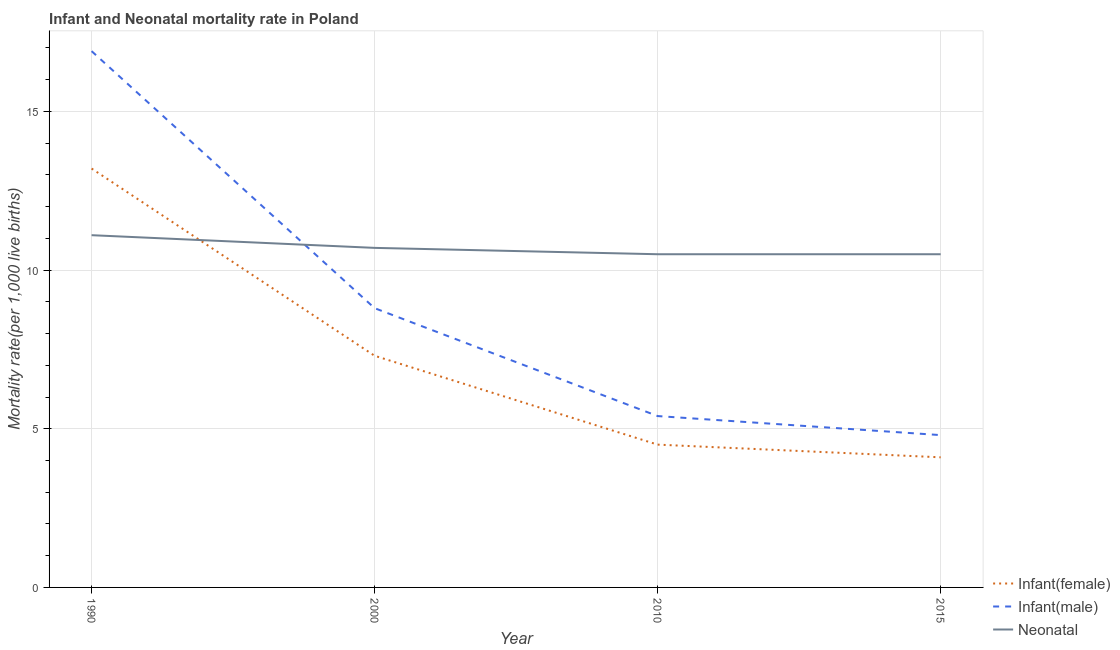Across all years, what is the maximum infant mortality rate(male)?
Provide a succinct answer. 16.9. In which year was the infant mortality rate(female) minimum?
Ensure brevity in your answer.  2015. What is the total infant mortality rate(female) in the graph?
Your answer should be very brief. 29.1. What is the difference between the neonatal mortality rate in 2000 and that in 2010?
Your answer should be very brief. 0.2. What is the difference between the neonatal mortality rate in 2015 and the infant mortality rate(male) in 1990?
Offer a terse response. -6.4. What is the average infant mortality rate(male) per year?
Offer a terse response. 8.97. In the year 2015, what is the difference between the infant mortality rate(male) and infant mortality rate(female)?
Offer a very short reply. 0.7. Is the infant mortality rate(female) in 2000 less than that in 2015?
Give a very brief answer. No. What is the difference between the highest and the second highest infant mortality rate(female)?
Your answer should be very brief. 5.9. What is the difference between the highest and the lowest infant mortality rate(male)?
Offer a very short reply. 12.1. In how many years, is the neonatal mortality rate greater than the average neonatal mortality rate taken over all years?
Keep it short and to the point. 1. Is the sum of the neonatal mortality rate in 2000 and 2010 greater than the maximum infant mortality rate(female) across all years?
Provide a short and direct response. Yes. Does the infant mortality rate(female) monotonically increase over the years?
Offer a terse response. No. Is the infant mortality rate(female) strictly greater than the infant mortality rate(male) over the years?
Your answer should be very brief. No. How many years are there in the graph?
Keep it short and to the point. 4. Are the values on the major ticks of Y-axis written in scientific E-notation?
Keep it short and to the point. No. What is the title of the graph?
Give a very brief answer. Infant and Neonatal mortality rate in Poland. Does "Domestic economy" appear as one of the legend labels in the graph?
Make the answer very short. No. What is the label or title of the X-axis?
Your answer should be very brief. Year. What is the label or title of the Y-axis?
Your answer should be very brief. Mortality rate(per 1,0 live births). What is the Mortality rate(per 1,000 live births) in Infant(male) in 1990?
Offer a very short reply. 16.9. What is the Mortality rate(per 1,000 live births) of Infant(female) in 2000?
Keep it short and to the point. 7.3. What is the Mortality rate(per 1,000 live births) in Infant(male) in 2010?
Give a very brief answer. 5.4. What is the Mortality rate(per 1,000 live births) in Neonatal  in 2010?
Keep it short and to the point. 10.5. What is the Mortality rate(per 1,000 live births) of Infant(female) in 2015?
Your response must be concise. 4.1. What is the Mortality rate(per 1,000 live births) in Neonatal  in 2015?
Give a very brief answer. 10.5. Across all years, what is the maximum Mortality rate(per 1,000 live births) of Infant(male)?
Offer a very short reply. 16.9. Across all years, what is the maximum Mortality rate(per 1,000 live births) of Neonatal ?
Provide a succinct answer. 11.1. What is the total Mortality rate(per 1,000 live births) of Infant(female) in the graph?
Your response must be concise. 29.1. What is the total Mortality rate(per 1,000 live births) in Infant(male) in the graph?
Provide a succinct answer. 35.9. What is the total Mortality rate(per 1,000 live births) of Neonatal  in the graph?
Give a very brief answer. 42.8. What is the difference between the Mortality rate(per 1,000 live births) in Infant(female) in 1990 and that in 2000?
Offer a very short reply. 5.9. What is the difference between the Mortality rate(per 1,000 live births) of Infant(female) in 1990 and that in 2010?
Your answer should be very brief. 8.7. What is the difference between the Mortality rate(per 1,000 live births) of Infant(male) in 1990 and that in 2010?
Provide a short and direct response. 11.5. What is the difference between the Mortality rate(per 1,000 live births) of Infant(female) in 1990 and that in 2015?
Offer a terse response. 9.1. What is the difference between the Mortality rate(per 1,000 live births) of Infant(male) in 1990 and that in 2015?
Your response must be concise. 12.1. What is the difference between the Mortality rate(per 1,000 live births) in Infant(female) in 2000 and that in 2010?
Offer a very short reply. 2.8. What is the difference between the Mortality rate(per 1,000 live births) of Infant(female) in 2000 and that in 2015?
Ensure brevity in your answer.  3.2. What is the difference between the Mortality rate(per 1,000 live births) of Infant(female) in 2010 and that in 2015?
Make the answer very short. 0.4. What is the difference between the Mortality rate(per 1,000 live births) in Infant(male) in 2010 and that in 2015?
Keep it short and to the point. 0.6. What is the difference between the Mortality rate(per 1,000 live births) in Neonatal  in 2010 and that in 2015?
Give a very brief answer. 0. What is the difference between the Mortality rate(per 1,000 live births) of Infant(female) in 1990 and the Mortality rate(per 1,000 live births) of Infant(male) in 2000?
Your answer should be compact. 4.4. What is the difference between the Mortality rate(per 1,000 live births) of Infant(male) in 1990 and the Mortality rate(per 1,000 live births) of Neonatal  in 2000?
Give a very brief answer. 6.2. What is the difference between the Mortality rate(per 1,000 live births) in Infant(male) in 1990 and the Mortality rate(per 1,000 live births) in Neonatal  in 2015?
Give a very brief answer. 6.4. What is the difference between the Mortality rate(per 1,000 live births) in Infant(female) in 2000 and the Mortality rate(per 1,000 live births) in Infant(male) in 2010?
Provide a succinct answer. 1.9. What is the difference between the Mortality rate(per 1,000 live births) in Infant(female) in 2000 and the Mortality rate(per 1,000 live births) in Neonatal  in 2010?
Keep it short and to the point. -3.2. What is the difference between the Mortality rate(per 1,000 live births) in Infant(female) in 2000 and the Mortality rate(per 1,000 live births) in Infant(male) in 2015?
Make the answer very short. 2.5. What is the difference between the Mortality rate(per 1,000 live births) of Infant(female) in 2010 and the Mortality rate(per 1,000 live births) of Infant(male) in 2015?
Provide a short and direct response. -0.3. What is the average Mortality rate(per 1,000 live births) in Infant(female) per year?
Your response must be concise. 7.28. What is the average Mortality rate(per 1,000 live births) in Infant(male) per year?
Offer a terse response. 8.97. In the year 1990, what is the difference between the Mortality rate(per 1,000 live births) in Infant(female) and Mortality rate(per 1,000 live births) in Neonatal ?
Provide a short and direct response. 2.1. In the year 2000, what is the difference between the Mortality rate(per 1,000 live births) of Infant(female) and Mortality rate(per 1,000 live births) of Infant(male)?
Ensure brevity in your answer.  -1.5. In the year 2010, what is the difference between the Mortality rate(per 1,000 live births) of Infant(male) and Mortality rate(per 1,000 live births) of Neonatal ?
Provide a short and direct response. -5.1. In the year 2015, what is the difference between the Mortality rate(per 1,000 live births) in Infant(female) and Mortality rate(per 1,000 live births) in Neonatal ?
Your answer should be compact. -6.4. What is the ratio of the Mortality rate(per 1,000 live births) in Infant(female) in 1990 to that in 2000?
Provide a succinct answer. 1.81. What is the ratio of the Mortality rate(per 1,000 live births) of Infant(male) in 1990 to that in 2000?
Make the answer very short. 1.92. What is the ratio of the Mortality rate(per 1,000 live births) in Neonatal  in 1990 to that in 2000?
Offer a terse response. 1.04. What is the ratio of the Mortality rate(per 1,000 live births) of Infant(female) in 1990 to that in 2010?
Offer a very short reply. 2.93. What is the ratio of the Mortality rate(per 1,000 live births) in Infant(male) in 1990 to that in 2010?
Offer a very short reply. 3.13. What is the ratio of the Mortality rate(per 1,000 live births) in Neonatal  in 1990 to that in 2010?
Offer a terse response. 1.06. What is the ratio of the Mortality rate(per 1,000 live births) in Infant(female) in 1990 to that in 2015?
Provide a succinct answer. 3.22. What is the ratio of the Mortality rate(per 1,000 live births) of Infant(male) in 1990 to that in 2015?
Provide a succinct answer. 3.52. What is the ratio of the Mortality rate(per 1,000 live births) in Neonatal  in 1990 to that in 2015?
Your answer should be compact. 1.06. What is the ratio of the Mortality rate(per 1,000 live births) of Infant(female) in 2000 to that in 2010?
Your answer should be compact. 1.62. What is the ratio of the Mortality rate(per 1,000 live births) of Infant(male) in 2000 to that in 2010?
Provide a succinct answer. 1.63. What is the ratio of the Mortality rate(per 1,000 live births) of Neonatal  in 2000 to that in 2010?
Your response must be concise. 1.02. What is the ratio of the Mortality rate(per 1,000 live births) of Infant(female) in 2000 to that in 2015?
Your answer should be very brief. 1.78. What is the ratio of the Mortality rate(per 1,000 live births) in Infant(male) in 2000 to that in 2015?
Offer a very short reply. 1.83. What is the ratio of the Mortality rate(per 1,000 live births) in Infant(female) in 2010 to that in 2015?
Provide a succinct answer. 1.1. What is the ratio of the Mortality rate(per 1,000 live births) of Neonatal  in 2010 to that in 2015?
Your response must be concise. 1. What is the difference between the highest and the second highest Mortality rate(per 1,000 live births) of Infant(male)?
Your answer should be compact. 8.1. What is the difference between the highest and the lowest Mortality rate(per 1,000 live births) of Infant(female)?
Keep it short and to the point. 9.1. What is the difference between the highest and the lowest Mortality rate(per 1,000 live births) of Infant(male)?
Give a very brief answer. 12.1. What is the difference between the highest and the lowest Mortality rate(per 1,000 live births) of Neonatal ?
Your answer should be compact. 0.6. 